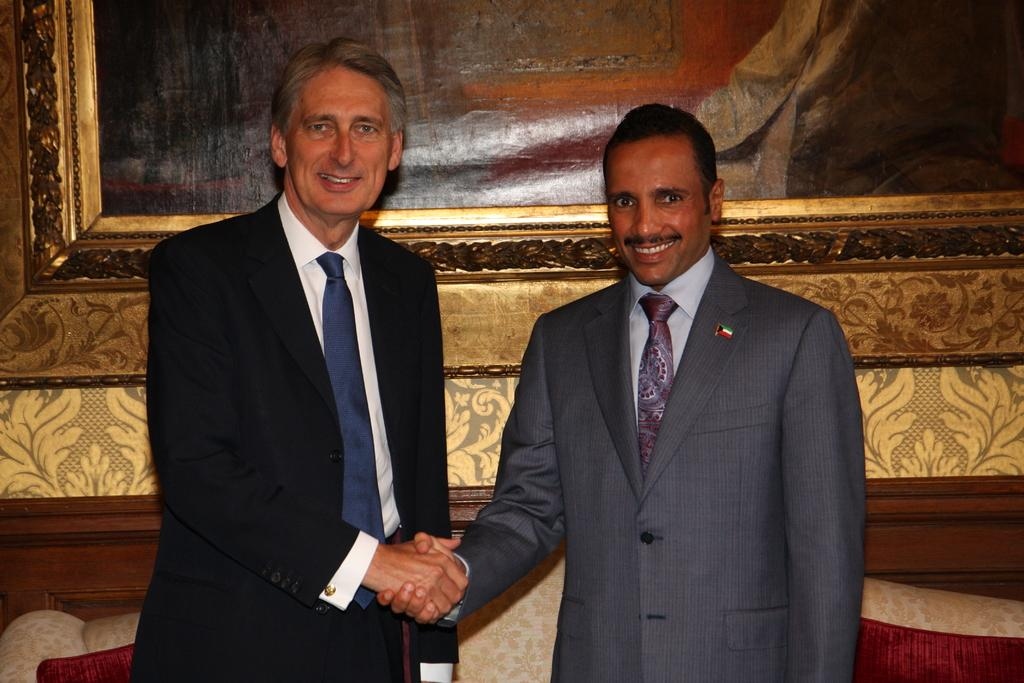How many people are in the image? There are two persons in the image. What are the two persons doing in the image? The two persons are standing and smiling, and they are shaking hands. What can be seen in the background of the image? There is a frame attached to the wall in the background, and there are some objects in the background. What type of swim can be seen in the image? There is no swim or swimming activity present in the image. How many people are in the crowd in the image? There is no crowd present in the image; it features two people standing and shaking hands. 